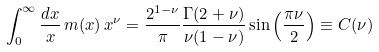Convert formula to latex. <formula><loc_0><loc_0><loc_500><loc_500>\int _ { 0 } ^ { \infty } \frac { d x } { x } \, m ( x ) \, x ^ { \nu } = \frac { 2 ^ { 1 - \nu } } { \pi } \frac { \Gamma ( 2 + \nu ) } { \nu ( 1 - \nu ) } \sin \left ( \frac { \pi \nu } { 2 } \right ) \equiv C ( \nu )</formula> 